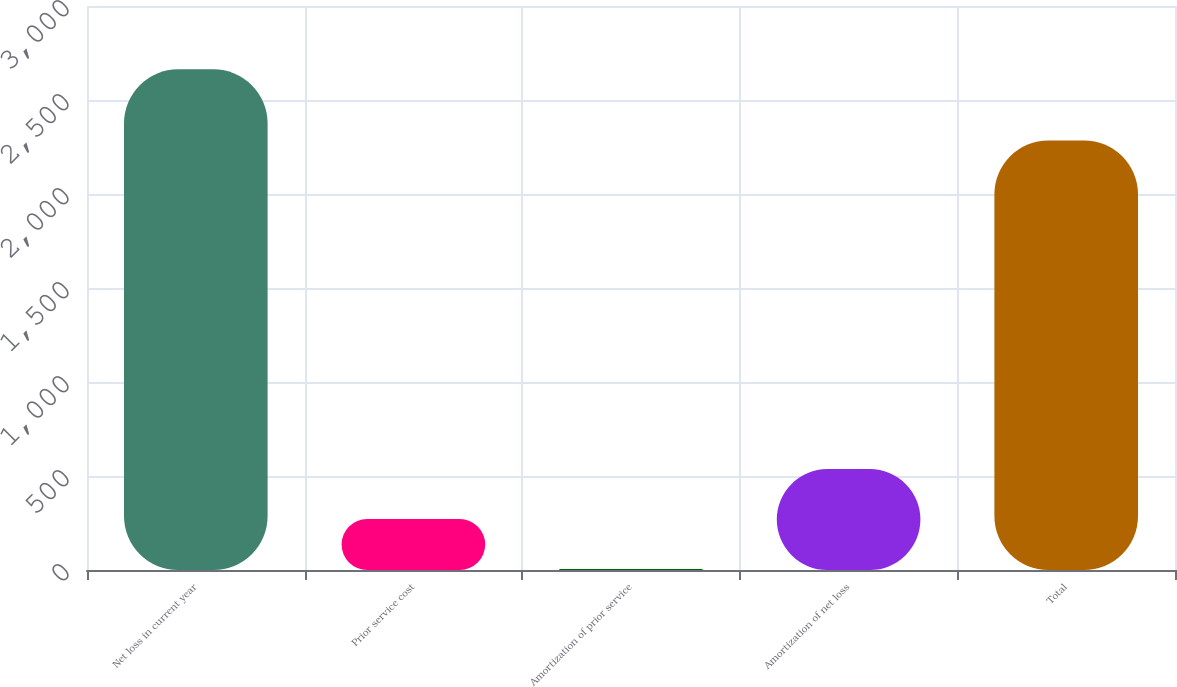Convert chart. <chart><loc_0><loc_0><loc_500><loc_500><bar_chart><fcel>Net loss in current year<fcel>Prior service cost<fcel>Amortization of prior service<fcel>Amortization of net loss<fcel>Total<nl><fcel>2663<fcel>270.8<fcel>5<fcel>536.6<fcel>2285<nl></chart> 